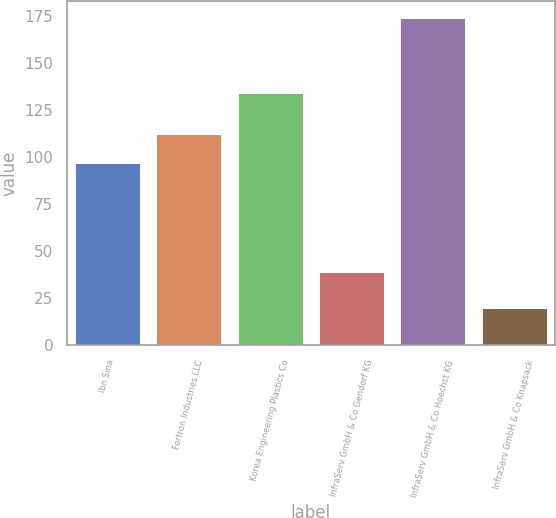Convert chart. <chart><loc_0><loc_0><loc_500><loc_500><bar_chart><fcel>Ibn Sina<fcel>Fortron Industries LLC<fcel>Korea Engineering Plastics Co<fcel>InfraServ GmbH & Co Gendorf KG<fcel>InfraServ GmbH & Co Hoechst KG<fcel>InfraServ GmbH & Co Knapsack<nl><fcel>97<fcel>112.4<fcel>134<fcel>39<fcel>174<fcel>20<nl></chart> 